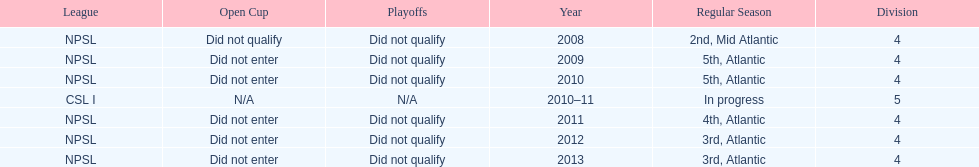What was the last year they came in 3rd place 2013. Could you parse the entire table as a dict? {'header': ['League', 'Open Cup', 'Playoffs', 'Year', 'Regular Season', 'Division'], 'rows': [['NPSL', 'Did not qualify', 'Did not qualify', '2008', '2nd, Mid Atlantic', '4'], ['NPSL', 'Did not enter', 'Did not qualify', '2009', '5th, Atlantic', '4'], ['NPSL', 'Did not enter', 'Did not qualify', '2010', '5th, Atlantic', '4'], ['CSL I', 'N/A', 'N/A', '2010–11', 'In progress', '5'], ['NPSL', 'Did not enter', 'Did not qualify', '2011', '4th, Atlantic', '4'], ['NPSL', 'Did not enter', 'Did not qualify', '2012', '3rd, Atlantic', '4'], ['NPSL', 'Did not enter', 'Did not qualify', '2013', '3rd, Atlantic', '4']]} 